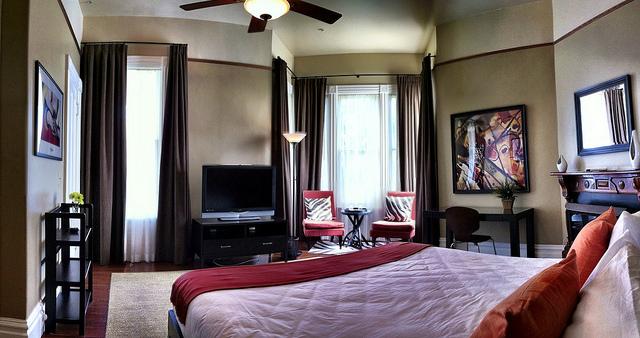Is the bed cover quilted?
Be succinct. Yes. Does someone like pillows?
Give a very brief answer. Yes. How many mirrors are in the room?
Answer briefly. 1. 